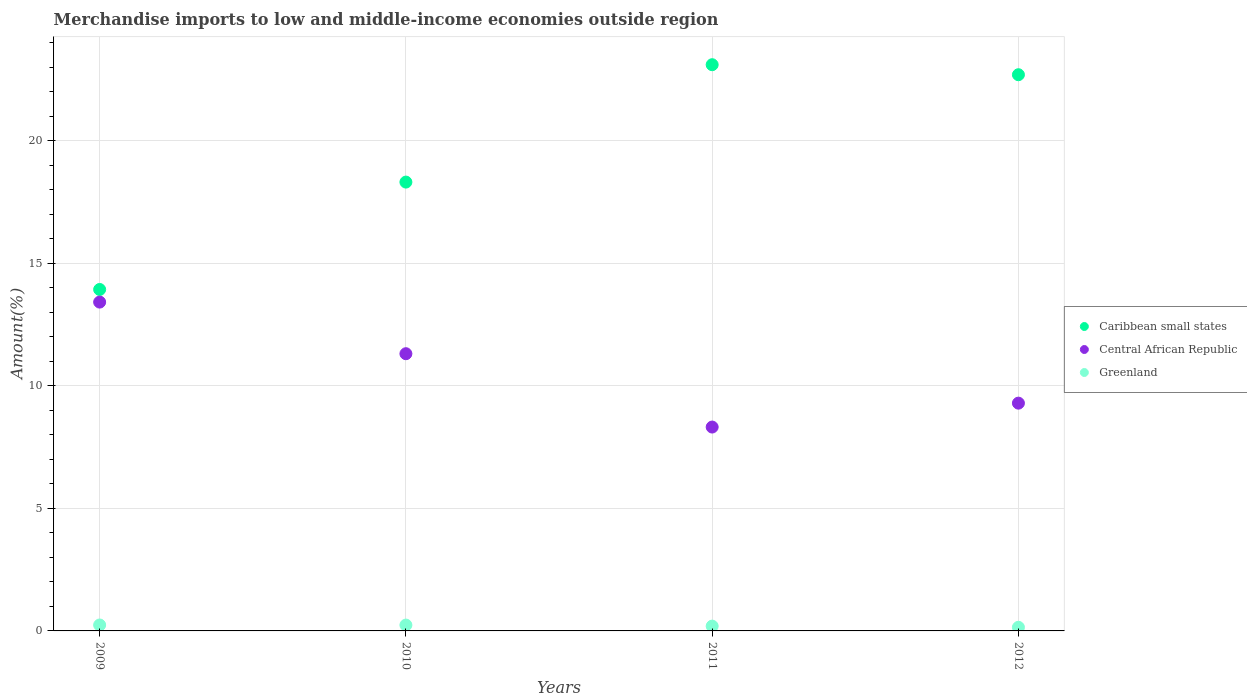Is the number of dotlines equal to the number of legend labels?
Your response must be concise. Yes. What is the percentage of amount earned from merchandise imports in Caribbean small states in 2010?
Give a very brief answer. 18.31. Across all years, what is the maximum percentage of amount earned from merchandise imports in Caribbean small states?
Make the answer very short. 23.1. Across all years, what is the minimum percentage of amount earned from merchandise imports in Central African Republic?
Keep it short and to the point. 8.32. What is the total percentage of amount earned from merchandise imports in Central African Republic in the graph?
Your answer should be compact. 42.34. What is the difference between the percentage of amount earned from merchandise imports in Caribbean small states in 2009 and that in 2012?
Your response must be concise. -8.76. What is the difference between the percentage of amount earned from merchandise imports in Caribbean small states in 2011 and the percentage of amount earned from merchandise imports in Central African Republic in 2012?
Provide a succinct answer. 13.81. What is the average percentage of amount earned from merchandise imports in Caribbean small states per year?
Make the answer very short. 19.51. In the year 2010, what is the difference between the percentage of amount earned from merchandise imports in Central African Republic and percentage of amount earned from merchandise imports in Greenland?
Make the answer very short. 11.07. What is the ratio of the percentage of amount earned from merchandise imports in Caribbean small states in 2010 to that in 2012?
Ensure brevity in your answer.  0.81. Is the percentage of amount earned from merchandise imports in Caribbean small states in 2009 less than that in 2012?
Your response must be concise. Yes. Is the difference between the percentage of amount earned from merchandise imports in Central African Republic in 2009 and 2010 greater than the difference between the percentage of amount earned from merchandise imports in Greenland in 2009 and 2010?
Give a very brief answer. Yes. What is the difference between the highest and the second highest percentage of amount earned from merchandise imports in Greenland?
Offer a terse response. 0. What is the difference between the highest and the lowest percentage of amount earned from merchandise imports in Central African Republic?
Ensure brevity in your answer.  5.1. In how many years, is the percentage of amount earned from merchandise imports in Greenland greater than the average percentage of amount earned from merchandise imports in Greenland taken over all years?
Provide a succinct answer. 2. Is the sum of the percentage of amount earned from merchandise imports in Caribbean small states in 2010 and 2012 greater than the maximum percentage of amount earned from merchandise imports in Greenland across all years?
Provide a short and direct response. Yes. Is it the case that in every year, the sum of the percentage of amount earned from merchandise imports in Greenland and percentage of amount earned from merchandise imports in Caribbean small states  is greater than the percentage of amount earned from merchandise imports in Central African Republic?
Your response must be concise. Yes. What is the difference between two consecutive major ticks on the Y-axis?
Provide a succinct answer. 5. Does the graph contain any zero values?
Provide a short and direct response. No. What is the title of the graph?
Your answer should be very brief. Merchandise imports to low and middle-income economies outside region. Does "Isle of Man" appear as one of the legend labels in the graph?
Give a very brief answer. No. What is the label or title of the Y-axis?
Ensure brevity in your answer.  Amount(%). What is the Amount(%) in Caribbean small states in 2009?
Offer a terse response. 13.93. What is the Amount(%) in Central African Republic in 2009?
Ensure brevity in your answer.  13.42. What is the Amount(%) of Greenland in 2009?
Your answer should be very brief. 0.24. What is the Amount(%) of Caribbean small states in 2010?
Provide a short and direct response. 18.31. What is the Amount(%) in Central African Republic in 2010?
Provide a short and direct response. 11.31. What is the Amount(%) in Greenland in 2010?
Offer a terse response. 0.24. What is the Amount(%) in Caribbean small states in 2011?
Make the answer very short. 23.1. What is the Amount(%) in Central African Republic in 2011?
Your answer should be very brief. 8.32. What is the Amount(%) in Greenland in 2011?
Give a very brief answer. 0.2. What is the Amount(%) of Caribbean small states in 2012?
Make the answer very short. 22.69. What is the Amount(%) in Central African Republic in 2012?
Provide a short and direct response. 9.29. What is the Amount(%) of Greenland in 2012?
Provide a short and direct response. 0.15. Across all years, what is the maximum Amount(%) of Caribbean small states?
Provide a succinct answer. 23.1. Across all years, what is the maximum Amount(%) in Central African Republic?
Ensure brevity in your answer.  13.42. Across all years, what is the maximum Amount(%) in Greenland?
Your response must be concise. 0.24. Across all years, what is the minimum Amount(%) in Caribbean small states?
Offer a terse response. 13.93. Across all years, what is the minimum Amount(%) in Central African Republic?
Your answer should be very brief. 8.32. Across all years, what is the minimum Amount(%) in Greenland?
Your response must be concise. 0.15. What is the total Amount(%) in Caribbean small states in the graph?
Your answer should be compact. 78.04. What is the total Amount(%) of Central African Republic in the graph?
Your answer should be very brief. 42.34. What is the total Amount(%) in Greenland in the graph?
Provide a succinct answer. 0.82. What is the difference between the Amount(%) in Caribbean small states in 2009 and that in 2010?
Your answer should be compact. -4.38. What is the difference between the Amount(%) of Central African Republic in 2009 and that in 2010?
Provide a short and direct response. 2.11. What is the difference between the Amount(%) in Greenland in 2009 and that in 2010?
Make the answer very short. 0. What is the difference between the Amount(%) of Caribbean small states in 2009 and that in 2011?
Your answer should be compact. -9.17. What is the difference between the Amount(%) in Central African Republic in 2009 and that in 2011?
Your answer should be compact. 5.1. What is the difference between the Amount(%) of Greenland in 2009 and that in 2011?
Offer a very short reply. 0.05. What is the difference between the Amount(%) in Caribbean small states in 2009 and that in 2012?
Provide a short and direct response. -8.76. What is the difference between the Amount(%) in Central African Republic in 2009 and that in 2012?
Offer a terse response. 4.12. What is the difference between the Amount(%) of Greenland in 2009 and that in 2012?
Your answer should be compact. 0.09. What is the difference between the Amount(%) in Caribbean small states in 2010 and that in 2011?
Your answer should be compact. -4.79. What is the difference between the Amount(%) in Central African Republic in 2010 and that in 2011?
Offer a very short reply. 2.99. What is the difference between the Amount(%) of Greenland in 2010 and that in 2011?
Provide a short and direct response. 0.04. What is the difference between the Amount(%) in Caribbean small states in 2010 and that in 2012?
Keep it short and to the point. -4.38. What is the difference between the Amount(%) of Central African Republic in 2010 and that in 2012?
Ensure brevity in your answer.  2.02. What is the difference between the Amount(%) in Greenland in 2010 and that in 2012?
Offer a terse response. 0.09. What is the difference between the Amount(%) of Caribbean small states in 2011 and that in 2012?
Provide a succinct answer. 0.41. What is the difference between the Amount(%) of Central African Republic in 2011 and that in 2012?
Ensure brevity in your answer.  -0.98. What is the difference between the Amount(%) in Greenland in 2011 and that in 2012?
Provide a short and direct response. 0.05. What is the difference between the Amount(%) in Caribbean small states in 2009 and the Amount(%) in Central African Republic in 2010?
Make the answer very short. 2.62. What is the difference between the Amount(%) of Caribbean small states in 2009 and the Amount(%) of Greenland in 2010?
Provide a succinct answer. 13.69. What is the difference between the Amount(%) of Central African Republic in 2009 and the Amount(%) of Greenland in 2010?
Keep it short and to the point. 13.18. What is the difference between the Amount(%) of Caribbean small states in 2009 and the Amount(%) of Central African Republic in 2011?
Provide a succinct answer. 5.61. What is the difference between the Amount(%) of Caribbean small states in 2009 and the Amount(%) of Greenland in 2011?
Provide a succinct answer. 13.74. What is the difference between the Amount(%) of Central African Republic in 2009 and the Amount(%) of Greenland in 2011?
Provide a short and direct response. 13.22. What is the difference between the Amount(%) of Caribbean small states in 2009 and the Amount(%) of Central African Republic in 2012?
Keep it short and to the point. 4.64. What is the difference between the Amount(%) in Caribbean small states in 2009 and the Amount(%) in Greenland in 2012?
Your answer should be very brief. 13.78. What is the difference between the Amount(%) in Central African Republic in 2009 and the Amount(%) in Greenland in 2012?
Make the answer very short. 13.27. What is the difference between the Amount(%) of Caribbean small states in 2010 and the Amount(%) of Central African Republic in 2011?
Offer a terse response. 9.99. What is the difference between the Amount(%) of Caribbean small states in 2010 and the Amount(%) of Greenland in 2011?
Provide a short and direct response. 18.12. What is the difference between the Amount(%) in Central African Republic in 2010 and the Amount(%) in Greenland in 2011?
Your answer should be very brief. 11.11. What is the difference between the Amount(%) in Caribbean small states in 2010 and the Amount(%) in Central African Republic in 2012?
Make the answer very short. 9.02. What is the difference between the Amount(%) in Caribbean small states in 2010 and the Amount(%) in Greenland in 2012?
Offer a terse response. 18.16. What is the difference between the Amount(%) in Central African Republic in 2010 and the Amount(%) in Greenland in 2012?
Make the answer very short. 11.16. What is the difference between the Amount(%) in Caribbean small states in 2011 and the Amount(%) in Central African Republic in 2012?
Give a very brief answer. 13.81. What is the difference between the Amount(%) in Caribbean small states in 2011 and the Amount(%) in Greenland in 2012?
Keep it short and to the point. 22.95. What is the difference between the Amount(%) in Central African Republic in 2011 and the Amount(%) in Greenland in 2012?
Your answer should be very brief. 8.17. What is the average Amount(%) in Caribbean small states per year?
Your answer should be very brief. 19.51. What is the average Amount(%) of Central African Republic per year?
Ensure brevity in your answer.  10.58. What is the average Amount(%) of Greenland per year?
Ensure brevity in your answer.  0.21. In the year 2009, what is the difference between the Amount(%) of Caribbean small states and Amount(%) of Central African Republic?
Your answer should be compact. 0.52. In the year 2009, what is the difference between the Amount(%) of Caribbean small states and Amount(%) of Greenland?
Ensure brevity in your answer.  13.69. In the year 2009, what is the difference between the Amount(%) in Central African Republic and Amount(%) in Greenland?
Provide a short and direct response. 13.17. In the year 2010, what is the difference between the Amount(%) in Caribbean small states and Amount(%) in Central African Republic?
Provide a short and direct response. 7. In the year 2010, what is the difference between the Amount(%) of Caribbean small states and Amount(%) of Greenland?
Keep it short and to the point. 18.07. In the year 2010, what is the difference between the Amount(%) of Central African Republic and Amount(%) of Greenland?
Your response must be concise. 11.07. In the year 2011, what is the difference between the Amount(%) in Caribbean small states and Amount(%) in Central African Republic?
Ensure brevity in your answer.  14.78. In the year 2011, what is the difference between the Amount(%) of Caribbean small states and Amount(%) of Greenland?
Offer a very short reply. 22.91. In the year 2011, what is the difference between the Amount(%) in Central African Republic and Amount(%) in Greenland?
Provide a short and direct response. 8.12. In the year 2012, what is the difference between the Amount(%) of Caribbean small states and Amount(%) of Central African Republic?
Provide a succinct answer. 13.4. In the year 2012, what is the difference between the Amount(%) of Caribbean small states and Amount(%) of Greenland?
Provide a short and direct response. 22.55. In the year 2012, what is the difference between the Amount(%) in Central African Republic and Amount(%) in Greenland?
Offer a very short reply. 9.15. What is the ratio of the Amount(%) of Caribbean small states in 2009 to that in 2010?
Your answer should be compact. 0.76. What is the ratio of the Amount(%) of Central African Republic in 2009 to that in 2010?
Offer a very short reply. 1.19. What is the ratio of the Amount(%) of Greenland in 2009 to that in 2010?
Ensure brevity in your answer.  1.01. What is the ratio of the Amount(%) in Caribbean small states in 2009 to that in 2011?
Provide a succinct answer. 0.6. What is the ratio of the Amount(%) in Central African Republic in 2009 to that in 2011?
Provide a short and direct response. 1.61. What is the ratio of the Amount(%) of Greenland in 2009 to that in 2011?
Offer a terse response. 1.23. What is the ratio of the Amount(%) in Caribbean small states in 2009 to that in 2012?
Provide a succinct answer. 0.61. What is the ratio of the Amount(%) of Central African Republic in 2009 to that in 2012?
Your answer should be compact. 1.44. What is the ratio of the Amount(%) of Greenland in 2009 to that in 2012?
Provide a succinct answer. 1.63. What is the ratio of the Amount(%) of Caribbean small states in 2010 to that in 2011?
Provide a succinct answer. 0.79. What is the ratio of the Amount(%) in Central African Republic in 2010 to that in 2011?
Offer a very short reply. 1.36. What is the ratio of the Amount(%) in Greenland in 2010 to that in 2011?
Your response must be concise. 1.22. What is the ratio of the Amount(%) of Caribbean small states in 2010 to that in 2012?
Your answer should be compact. 0.81. What is the ratio of the Amount(%) of Central African Republic in 2010 to that in 2012?
Offer a terse response. 1.22. What is the ratio of the Amount(%) in Greenland in 2010 to that in 2012?
Give a very brief answer. 1.61. What is the ratio of the Amount(%) in Central African Republic in 2011 to that in 2012?
Offer a terse response. 0.9. What is the ratio of the Amount(%) in Greenland in 2011 to that in 2012?
Your response must be concise. 1.32. What is the difference between the highest and the second highest Amount(%) of Caribbean small states?
Give a very brief answer. 0.41. What is the difference between the highest and the second highest Amount(%) of Central African Republic?
Make the answer very short. 2.11. What is the difference between the highest and the second highest Amount(%) in Greenland?
Make the answer very short. 0. What is the difference between the highest and the lowest Amount(%) in Caribbean small states?
Provide a succinct answer. 9.17. What is the difference between the highest and the lowest Amount(%) of Central African Republic?
Give a very brief answer. 5.1. What is the difference between the highest and the lowest Amount(%) in Greenland?
Your response must be concise. 0.09. 